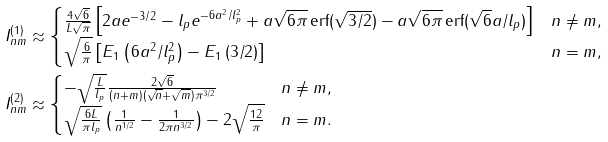Convert formula to latex. <formula><loc_0><loc_0><loc_500><loc_500>I ^ { ( 1 ) } _ { n m } & \approx \begin{cases} \frac { 4 \sqrt { 6 } } { L \sqrt { \pi } } \left [ 2 a e ^ { - 3 / 2 } - l _ { p } e ^ { - 6 a ^ { 2 } / l _ { p } ^ { 2 } } + a \sqrt { 6 \pi } \, \text {erf} ( \sqrt { 3 / 2 } ) - a \sqrt { 6 \pi } \, \text {erf} ( \sqrt { 6 } a / l _ { p } ) \right ] & n \ne m , \\ \sqrt { \frac { 6 } { \pi } } \left [ E _ { 1 } \left ( 6 a ^ { 2 } / l _ { p } ^ { 2 } \right ) - E _ { 1 } \left ( 3 / 2 \right ) \right ] & n = m , \end{cases} \\ I ^ { ( 2 ) } _ { n m } & \approx \begin{cases} - \sqrt { \frac { L } { l _ { p } } } \frac { 2 \sqrt { 6 } } { ( n + m ) ( \sqrt { n } + \sqrt { m } ) \pi ^ { 3 / 2 } } & n \ne m , \\ \sqrt { \frac { 6 L } { \pi l _ { p } } } \left ( \frac { 1 } { n ^ { 1 / 2 } } - \frac { 1 } { 2 \pi n ^ { 3 / 2 } } \right ) - 2 \sqrt { \frac { 1 2 } { \pi } } & n = m . \end{cases}</formula> 